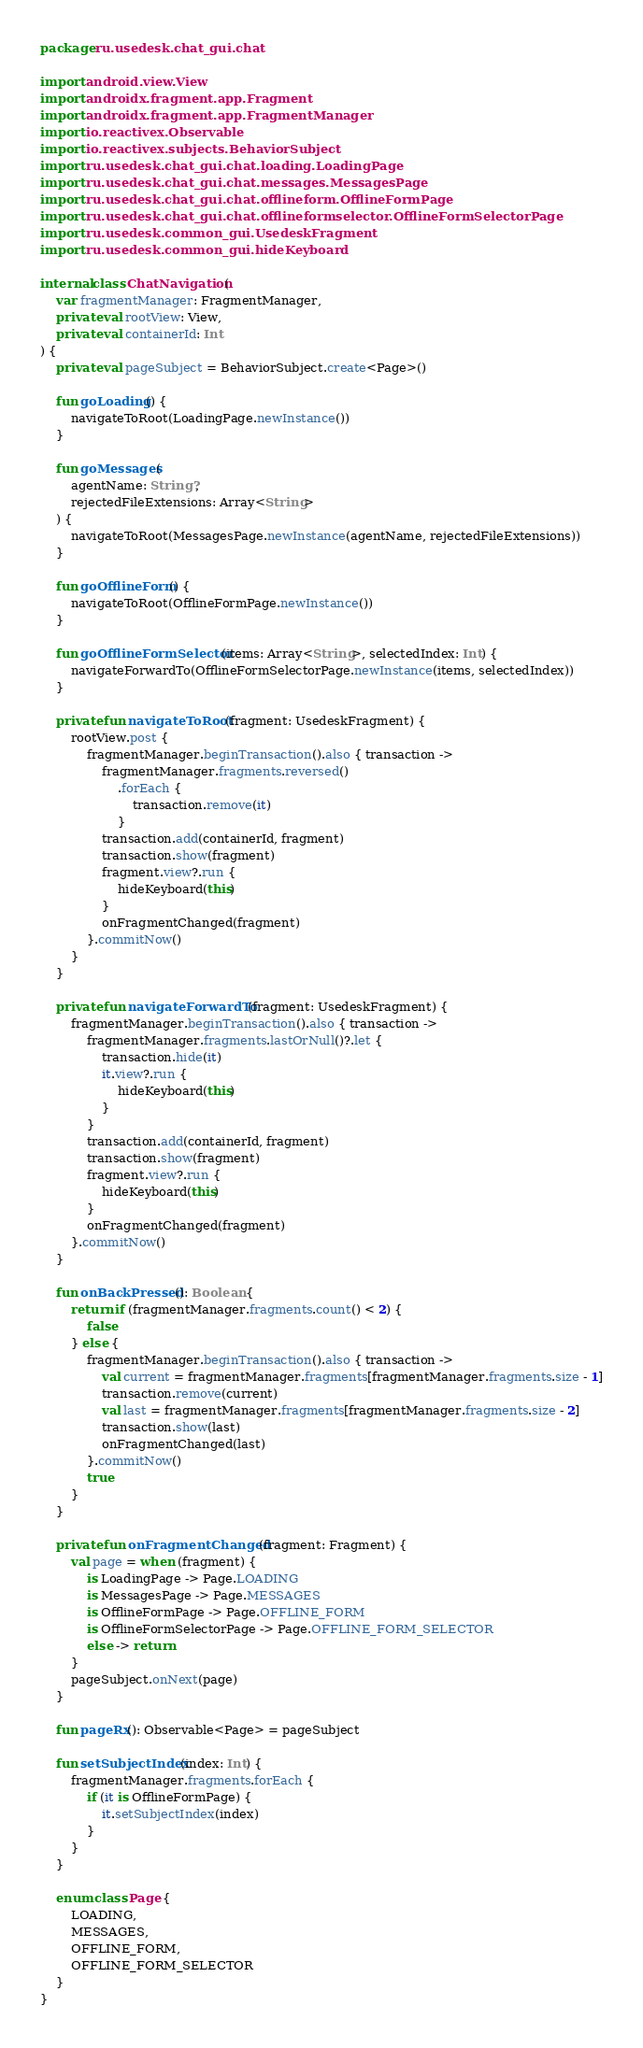<code> <loc_0><loc_0><loc_500><loc_500><_Kotlin_>package ru.usedesk.chat_gui.chat

import android.view.View
import androidx.fragment.app.Fragment
import androidx.fragment.app.FragmentManager
import io.reactivex.Observable
import io.reactivex.subjects.BehaviorSubject
import ru.usedesk.chat_gui.chat.loading.LoadingPage
import ru.usedesk.chat_gui.chat.messages.MessagesPage
import ru.usedesk.chat_gui.chat.offlineform.OfflineFormPage
import ru.usedesk.chat_gui.chat.offlineformselector.OfflineFormSelectorPage
import ru.usedesk.common_gui.UsedeskFragment
import ru.usedesk.common_gui.hideKeyboard

internal class ChatNavigation(
    var fragmentManager: FragmentManager,
    private val rootView: View,
    private val containerId: Int
) {
    private val pageSubject = BehaviorSubject.create<Page>()

    fun goLoading() {
        navigateToRoot(LoadingPage.newInstance())
    }

    fun goMessages(
        agentName: String?,
        rejectedFileExtensions: Array<String>
    ) {
        navigateToRoot(MessagesPage.newInstance(agentName, rejectedFileExtensions))
    }

    fun goOfflineForm() {
        navigateToRoot(OfflineFormPage.newInstance())
    }

    fun goOfflineFormSelector(items: Array<String>, selectedIndex: Int) {
        navigateForwardTo(OfflineFormSelectorPage.newInstance(items, selectedIndex))
    }

    private fun navigateToRoot(fragment: UsedeskFragment) {
        rootView.post {
            fragmentManager.beginTransaction().also { transaction ->
                fragmentManager.fragments.reversed()
                    .forEach {
                        transaction.remove(it)
                    }
                transaction.add(containerId, fragment)
                transaction.show(fragment)
                fragment.view?.run {
                    hideKeyboard(this)
                }
                onFragmentChanged(fragment)
            }.commitNow()
        }
    }

    private fun navigateForwardTo(fragment: UsedeskFragment) {
        fragmentManager.beginTransaction().also { transaction ->
            fragmentManager.fragments.lastOrNull()?.let {
                transaction.hide(it)
                it.view?.run {
                    hideKeyboard(this)
                }
            }
            transaction.add(containerId, fragment)
            transaction.show(fragment)
            fragment.view?.run {
                hideKeyboard(this)
            }
            onFragmentChanged(fragment)
        }.commitNow()
    }

    fun onBackPressed(): Boolean {
        return if (fragmentManager.fragments.count() < 2) {
            false
        } else {
            fragmentManager.beginTransaction().also { transaction ->
                val current = fragmentManager.fragments[fragmentManager.fragments.size - 1]
                transaction.remove(current)
                val last = fragmentManager.fragments[fragmentManager.fragments.size - 2]
                transaction.show(last)
                onFragmentChanged(last)
            }.commitNow()
            true
        }
    }

    private fun onFragmentChanged(fragment: Fragment) {
        val page = when (fragment) {
            is LoadingPage -> Page.LOADING
            is MessagesPage -> Page.MESSAGES
            is OfflineFormPage -> Page.OFFLINE_FORM
            is OfflineFormSelectorPage -> Page.OFFLINE_FORM_SELECTOR
            else -> return
        }
        pageSubject.onNext(page)
    }

    fun pageRx(): Observable<Page> = pageSubject

    fun setSubjectIndex(index: Int) {
        fragmentManager.fragments.forEach {
            if (it is OfflineFormPage) {
                it.setSubjectIndex(index)
            }
        }
    }

    enum class Page {
        LOADING,
        MESSAGES,
        OFFLINE_FORM,
        OFFLINE_FORM_SELECTOR
    }
}</code> 